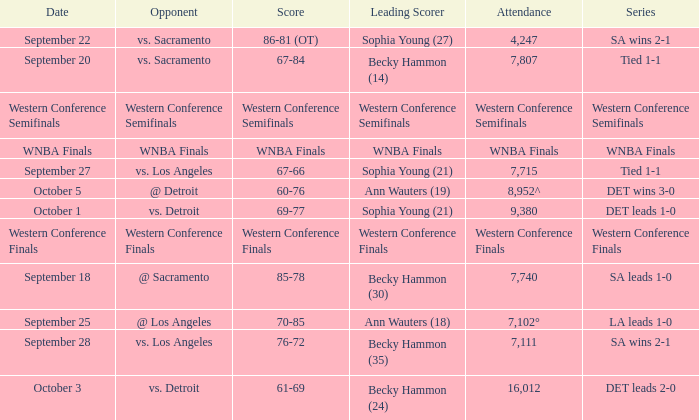Could you help me parse every detail presented in this table? {'header': ['Date', 'Opponent', 'Score', 'Leading Scorer', 'Attendance', 'Series'], 'rows': [['September 22', 'vs. Sacramento', '86-81 (OT)', 'Sophia Young (27)', '4,247', 'SA wins 2-1'], ['September 20', 'vs. Sacramento', '67-84', 'Becky Hammon (14)', '7,807', 'Tied 1-1'], ['Western Conference Semifinals', 'Western Conference Semifinals', 'Western Conference Semifinals', 'Western Conference Semifinals', 'Western Conference Semifinals', 'Western Conference Semifinals'], ['WNBA Finals', 'WNBA Finals', 'WNBA Finals', 'WNBA Finals', 'WNBA Finals', 'WNBA Finals'], ['September 27', 'vs. Los Angeles', '67-66', 'Sophia Young (21)', '7,715', 'Tied 1-1'], ['October 5', '@ Detroit', '60-76', 'Ann Wauters (19)', '8,952^', 'DET wins 3-0'], ['October 1', 'vs. Detroit', '69-77', 'Sophia Young (21)', '9,380', 'DET leads 1-0'], ['Western Conference Finals', 'Western Conference Finals', 'Western Conference Finals', 'Western Conference Finals', 'Western Conference Finals', 'Western Conference Finals'], ['September 18', '@ Sacramento', '85-78', 'Becky Hammon (30)', '7,740', 'SA leads 1-0'], ['September 25', '@ Los Angeles', '70-85', 'Ann Wauters (18)', '7,102°', 'LA leads 1-0'], ['September 28', 'vs. Los Angeles', '76-72', 'Becky Hammon (35)', '7,111', 'SA wins 2-1'], ['October 3', 'vs. Detroit', '61-69', 'Becky Hammon (24)', '16,012', 'DET leads 2-0']]} What is the attendance of the western conference finals series? Western Conference Finals. 